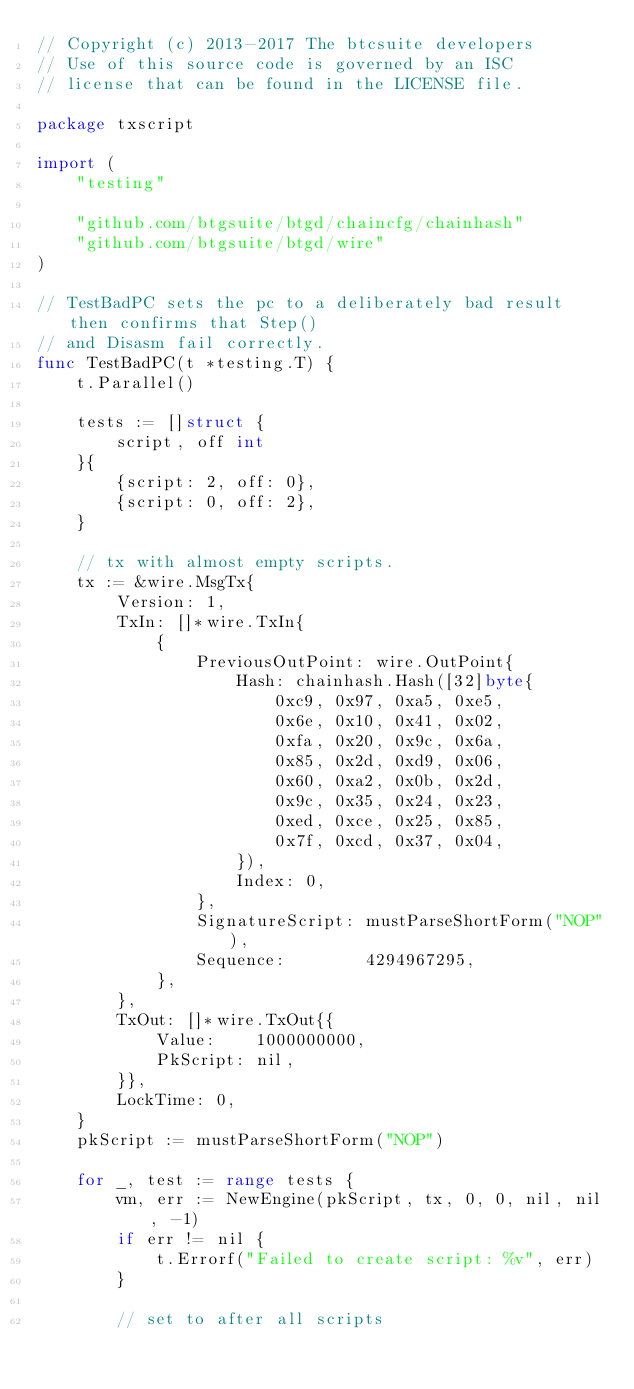<code> <loc_0><loc_0><loc_500><loc_500><_Go_>// Copyright (c) 2013-2017 The btcsuite developers
// Use of this source code is governed by an ISC
// license that can be found in the LICENSE file.

package txscript

import (
	"testing"

	"github.com/btgsuite/btgd/chaincfg/chainhash"
	"github.com/btgsuite/btgd/wire"
)

// TestBadPC sets the pc to a deliberately bad result then confirms that Step()
// and Disasm fail correctly.
func TestBadPC(t *testing.T) {
	t.Parallel()

	tests := []struct {
		script, off int
	}{
		{script: 2, off: 0},
		{script: 0, off: 2},
	}

	// tx with almost empty scripts.
	tx := &wire.MsgTx{
		Version: 1,
		TxIn: []*wire.TxIn{
			{
				PreviousOutPoint: wire.OutPoint{
					Hash: chainhash.Hash([32]byte{
						0xc9, 0x97, 0xa5, 0xe5,
						0x6e, 0x10, 0x41, 0x02,
						0xfa, 0x20, 0x9c, 0x6a,
						0x85, 0x2d, 0xd9, 0x06,
						0x60, 0xa2, 0x0b, 0x2d,
						0x9c, 0x35, 0x24, 0x23,
						0xed, 0xce, 0x25, 0x85,
						0x7f, 0xcd, 0x37, 0x04,
					}),
					Index: 0,
				},
				SignatureScript: mustParseShortForm("NOP"),
				Sequence:        4294967295,
			},
		},
		TxOut: []*wire.TxOut{{
			Value:    1000000000,
			PkScript: nil,
		}},
		LockTime: 0,
	}
	pkScript := mustParseShortForm("NOP")

	for _, test := range tests {
		vm, err := NewEngine(pkScript, tx, 0, 0, nil, nil, -1)
		if err != nil {
			t.Errorf("Failed to create script: %v", err)
		}

		// set to after all scripts</code> 